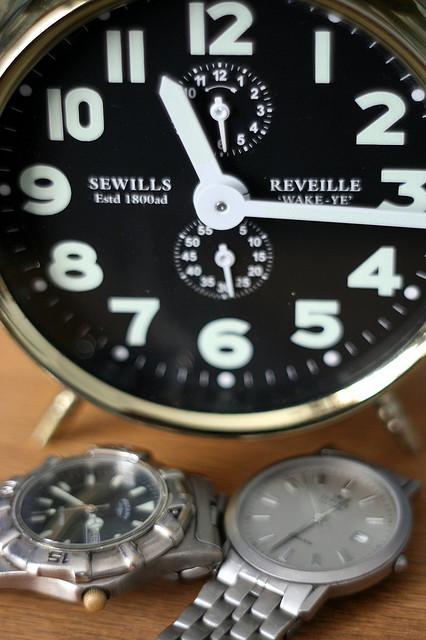What color do they all have in common?
Write a very short answer. Silver. Can the big clock be worn around the wrist?
Concise answer only. No. Would this clock have an alarm set?
Write a very short answer. Yes. 